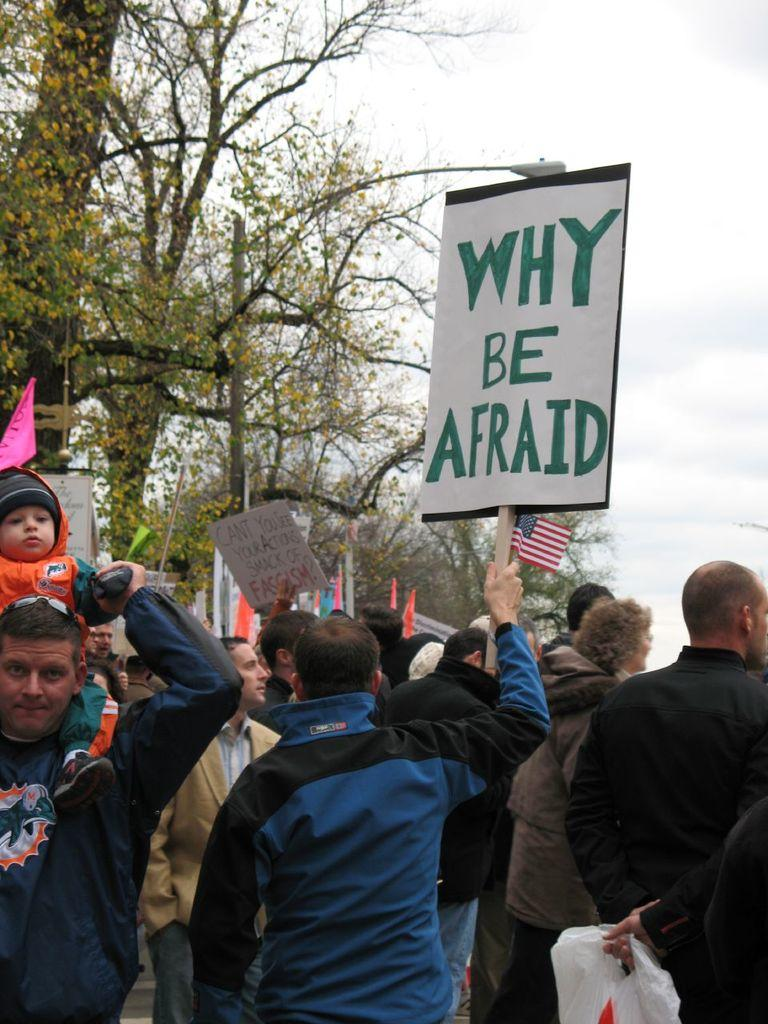<image>
Write a terse but informative summary of the picture. People are protesting and holding up a sign not be afraid. 